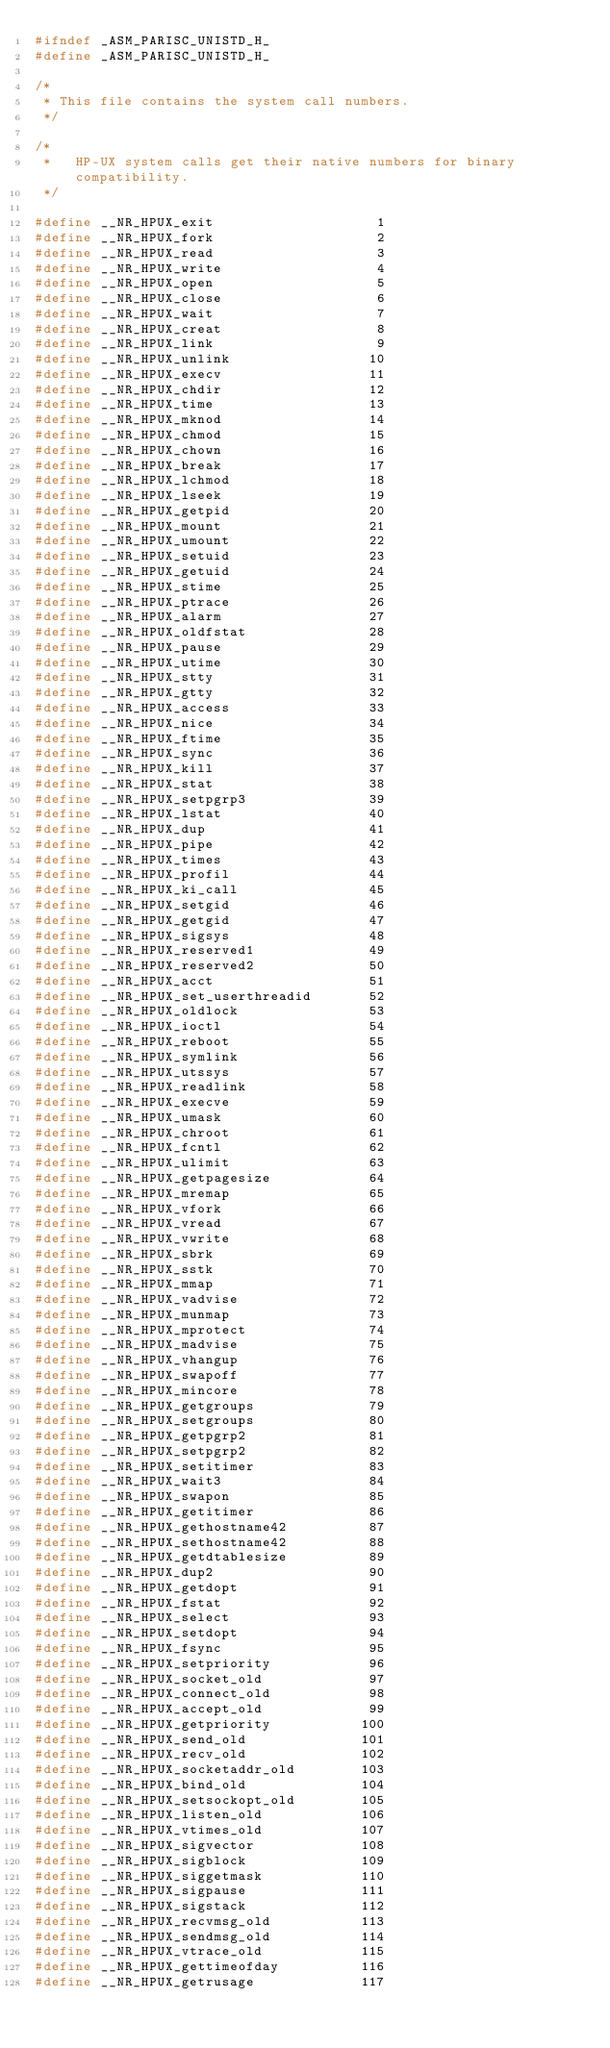Convert code to text. <code><loc_0><loc_0><loc_500><loc_500><_C_>#ifndef _ASM_PARISC_UNISTD_H_
#define _ASM_PARISC_UNISTD_H_

/*
 * This file contains the system call numbers.
 */

/*
 *   HP-UX system calls get their native numbers for binary compatibility.
 */

#define __NR_HPUX_exit                    1
#define __NR_HPUX_fork                    2
#define __NR_HPUX_read                    3
#define __NR_HPUX_write                   4
#define __NR_HPUX_open                    5
#define __NR_HPUX_close                   6
#define __NR_HPUX_wait                    7
#define __NR_HPUX_creat                   8
#define __NR_HPUX_link                    9
#define __NR_HPUX_unlink                 10
#define __NR_HPUX_execv                  11
#define __NR_HPUX_chdir                  12
#define __NR_HPUX_time                   13
#define __NR_HPUX_mknod                  14
#define __NR_HPUX_chmod                  15
#define __NR_HPUX_chown                  16
#define __NR_HPUX_break                  17
#define __NR_HPUX_lchmod                 18
#define __NR_HPUX_lseek                  19
#define __NR_HPUX_getpid                 20
#define __NR_HPUX_mount                  21
#define __NR_HPUX_umount                 22
#define __NR_HPUX_setuid                 23
#define __NR_HPUX_getuid                 24
#define __NR_HPUX_stime                  25
#define __NR_HPUX_ptrace                 26
#define __NR_HPUX_alarm                  27
#define __NR_HPUX_oldfstat               28
#define __NR_HPUX_pause                  29
#define __NR_HPUX_utime                  30
#define __NR_HPUX_stty                   31
#define __NR_HPUX_gtty                   32
#define __NR_HPUX_access                 33
#define __NR_HPUX_nice                   34
#define __NR_HPUX_ftime                  35
#define __NR_HPUX_sync                   36
#define __NR_HPUX_kill                   37
#define __NR_HPUX_stat                   38
#define __NR_HPUX_setpgrp3               39
#define __NR_HPUX_lstat                  40
#define __NR_HPUX_dup                    41
#define __NR_HPUX_pipe                   42
#define __NR_HPUX_times                  43
#define __NR_HPUX_profil                 44
#define __NR_HPUX_ki_call                45
#define __NR_HPUX_setgid                 46
#define __NR_HPUX_getgid                 47
#define __NR_HPUX_sigsys                 48
#define __NR_HPUX_reserved1              49
#define __NR_HPUX_reserved2              50
#define __NR_HPUX_acct                   51
#define __NR_HPUX_set_userthreadid       52
#define __NR_HPUX_oldlock                53
#define __NR_HPUX_ioctl                  54
#define __NR_HPUX_reboot                 55
#define __NR_HPUX_symlink                56
#define __NR_HPUX_utssys                 57
#define __NR_HPUX_readlink               58
#define __NR_HPUX_execve                 59
#define __NR_HPUX_umask                  60
#define __NR_HPUX_chroot                 61
#define __NR_HPUX_fcntl                  62
#define __NR_HPUX_ulimit                 63
#define __NR_HPUX_getpagesize            64
#define __NR_HPUX_mremap                 65
#define __NR_HPUX_vfork                  66
#define __NR_HPUX_vread                  67
#define __NR_HPUX_vwrite                 68
#define __NR_HPUX_sbrk                   69
#define __NR_HPUX_sstk                   70
#define __NR_HPUX_mmap                   71
#define __NR_HPUX_vadvise                72
#define __NR_HPUX_munmap                 73
#define __NR_HPUX_mprotect               74
#define __NR_HPUX_madvise                75
#define __NR_HPUX_vhangup                76
#define __NR_HPUX_swapoff                77
#define __NR_HPUX_mincore                78
#define __NR_HPUX_getgroups              79
#define __NR_HPUX_setgroups              80
#define __NR_HPUX_getpgrp2               81
#define __NR_HPUX_setpgrp2               82
#define __NR_HPUX_setitimer              83
#define __NR_HPUX_wait3                  84
#define __NR_HPUX_swapon                 85
#define __NR_HPUX_getitimer              86
#define __NR_HPUX_gethostname42          87
#define __NR_HPUX_sethostname42          88
#define __NR_HPUX_getdtablesize          89
#define __NR_HPUX_dup2                   90
#define __NR_HPUX_getdopt                91
#define __NR_HPUX_fstat                  92
#define __NR_HPUX_select                 93
#define __NR_HPUX_setdopt                94
#define __NR_HPUX_fsync                  95
#define __NR_HPUX_setpriority            96
#define __NR_HPUX_socket_old             97
#define __NR_HPUX_connect_old            98
#define __NR_HPUX_accept_old             99
#define __NR_HPUX_getpriority           100
#define __NR_HPUX_send_old              101
#define __NR_HPUX_recv_old              102
#define __NR_HPUX_socketaddr_old        103
#define __NR_HPUX_bind_old              104
#define __NR_HPUX_setsockopt_old        105
#define __NR_HPUX_listen_old            106
#define __NR_HPUX_vtimes_old            107
#define __NR_HPUX_sigvector             108
#define __NR_HPUX_sigblock              109
#define __NR_HPUX_siggetmask            110
#define __NR_HPUX_sigpause              111
#define __NR_HPUX_sigstack              112
#define __NR_HPUX_recvmsg_old           113
#define __NR_HPUX_sendmsg_old           114
#define __NR_HPUX_vtrace_old            115
#define __NR_HPUX_gettimeofday          116
#define __NR_HPUX_getrusage             117</code> 